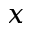Convert formula to latex. <formula><loc_0><loc_0><loc_500><loc_500>x</formula> 